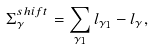Convert formula to latex. <formula><loc_0><loc_0><loc_500><loc_500>\Sigma _ { \gamma } ^ { s h i f t } = \sum _ { \gamma _ { 1 } } l _ { \gamma _ { 1 } } - l _ { \gamma } ,</formula> 